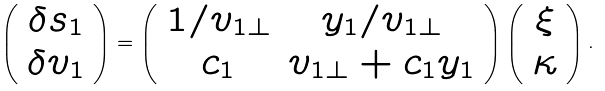<formula> <loc_0><loc_0><loc_500><loc_500>\left ( \begin{array} { c } \delta s _ { 1 } \\ \delta v _ { 1 } \end{array} \right ) = \left ( \begin{array} { c c } 1 / v _ { 1 \perp } & y _ { 1 } / v _ { 1 \perp } \\ c _ { 1 } & v _ { 1 \perp } + c _ { 1 } y _ { 1 } \end{array} \right ) \left ( \begin{array} { c } \xi \\ \kappa \end{array} \right ) .</formula> 